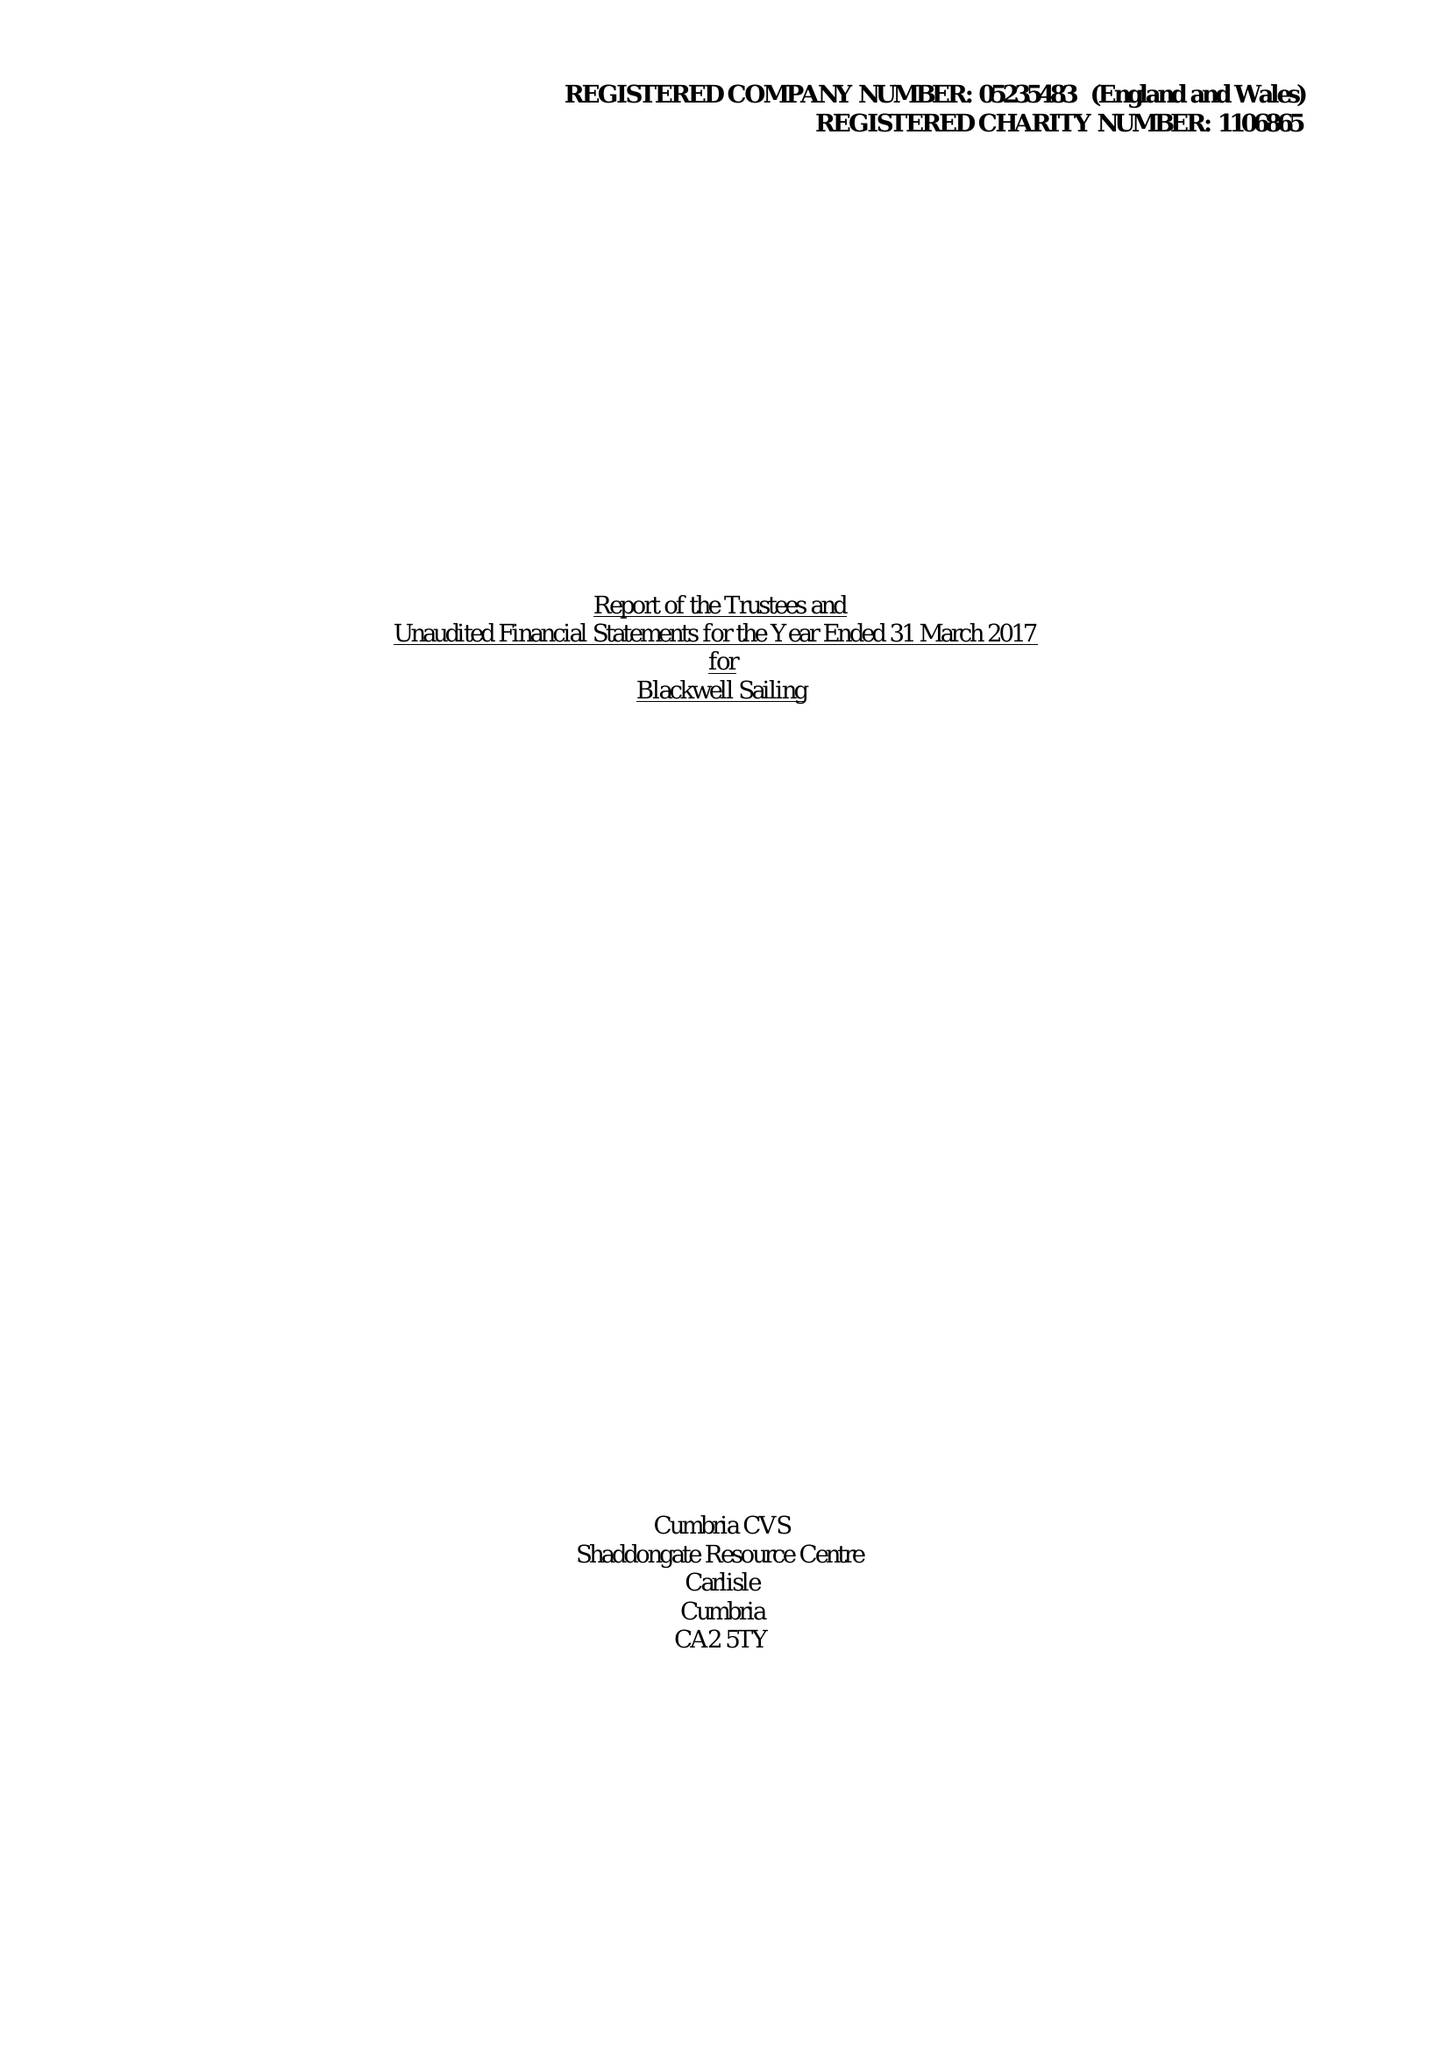What is the value for the charity_number?
Answer the question using a single word or phrase. 1106865 